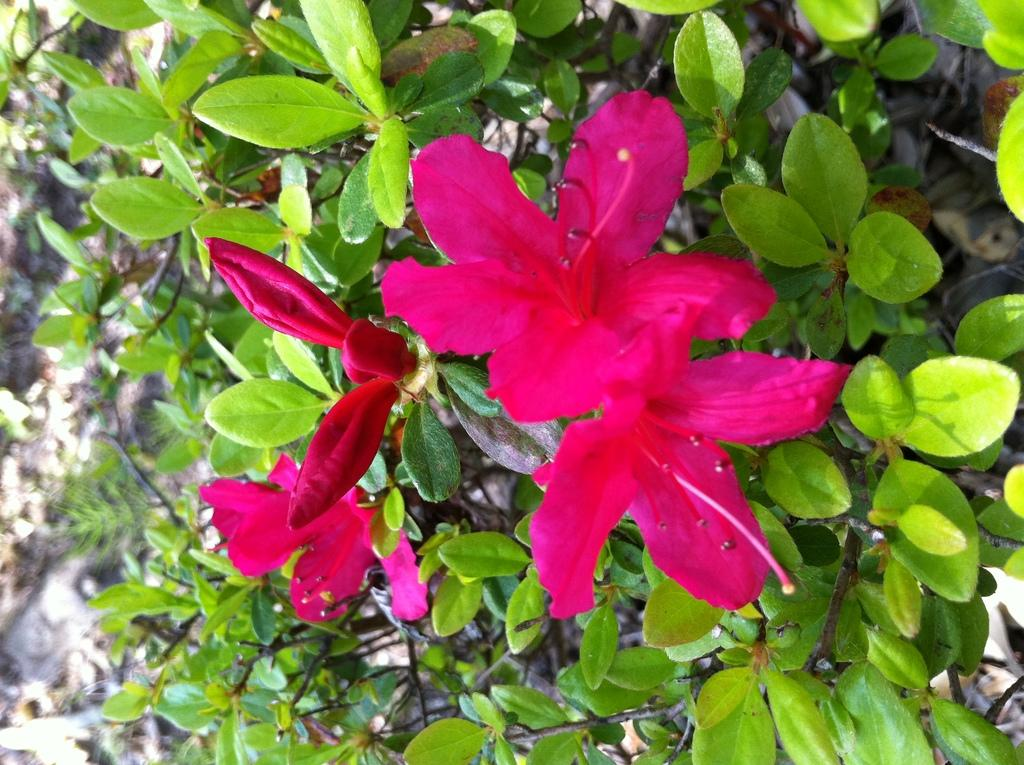What type of plant life can be seen in the image? There are flowers in the image. What parts of the flowers are visible? Leaves and stems are visible around the flowers. What additional plant material can be seen on the surface in the image? Dry leaves are on the surface in the image. What type of punishment is being administered to the kitty in the image? There is no kitty present in the image, and therefore no punishment is being administered. 